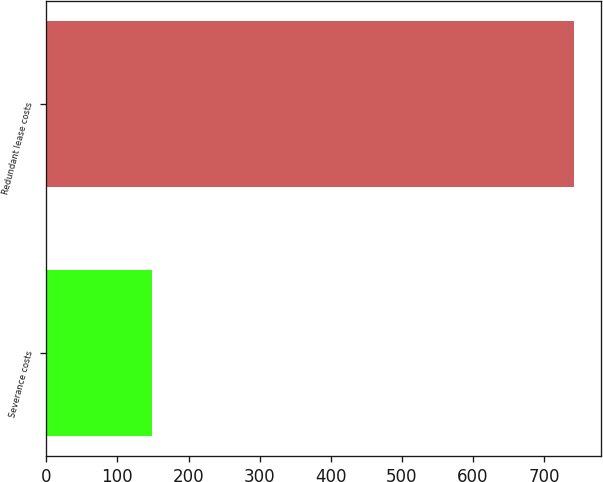Convert chart to OTSL. <chart><loc_0><loc_0><loc_500><loc_500><bar_chart><fcel>Severance costs<fcel>Redundant lease costs<nl><fcel>149<fcel>742<nl></chart> 